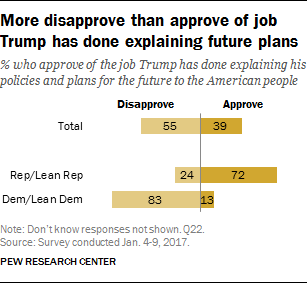Give some essential details in this illustration. The sum value of disapproved and approved total distribution is 94. The lowest value of the yellow bar is 13. 